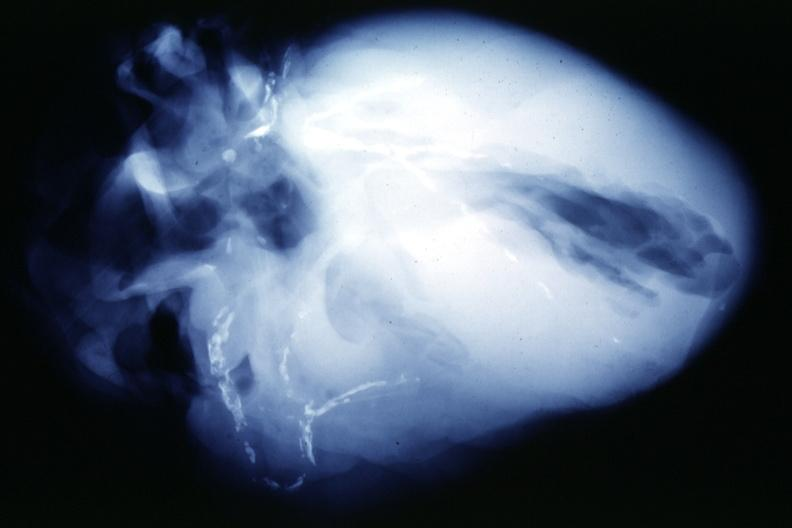what is present?
Answer the question using a single word or phrase. Cardiovascular 